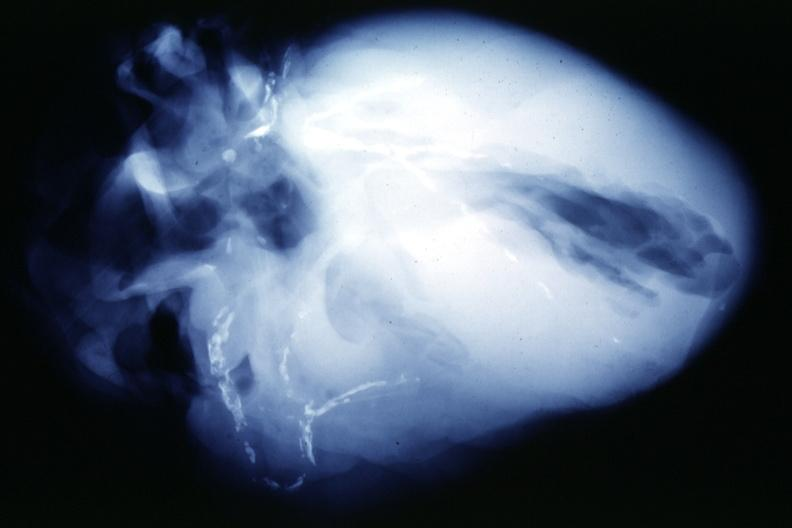what is present?
Answer the question using a single word or phrase. Cardiovascular 